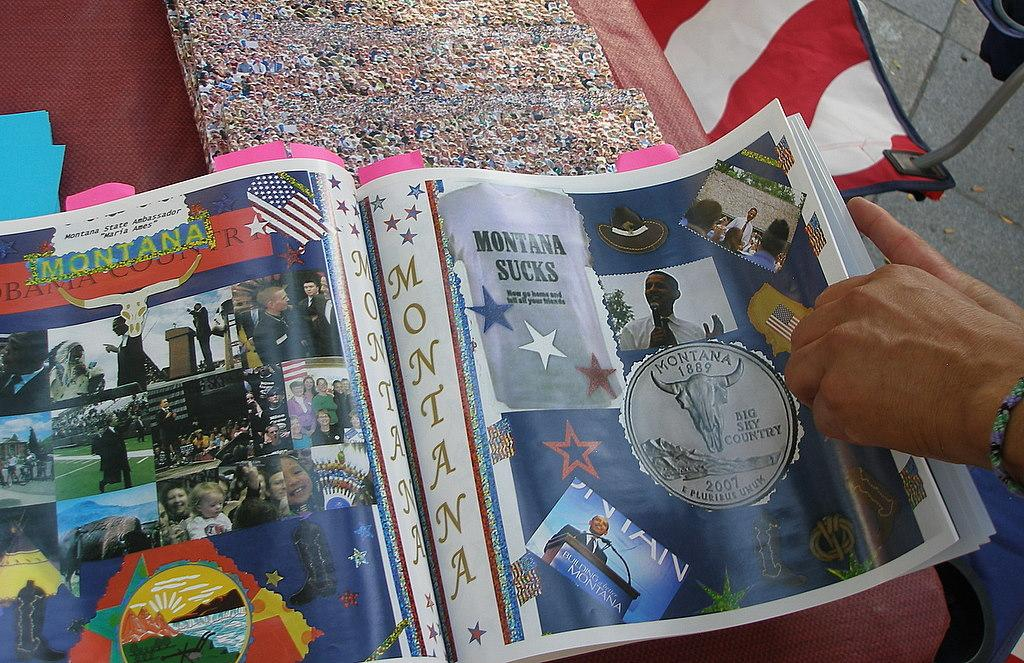<image>
Relay a brief, clear account of the picture shown. A two page article in a magazine about Montana. 